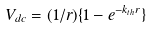<formula> <loc_0><loc_0><loc_500><loc_500>V _ { d c } = ( 1 / r ) \{ 1 - e ^ { - k _ { t h } r } \}</formula> 